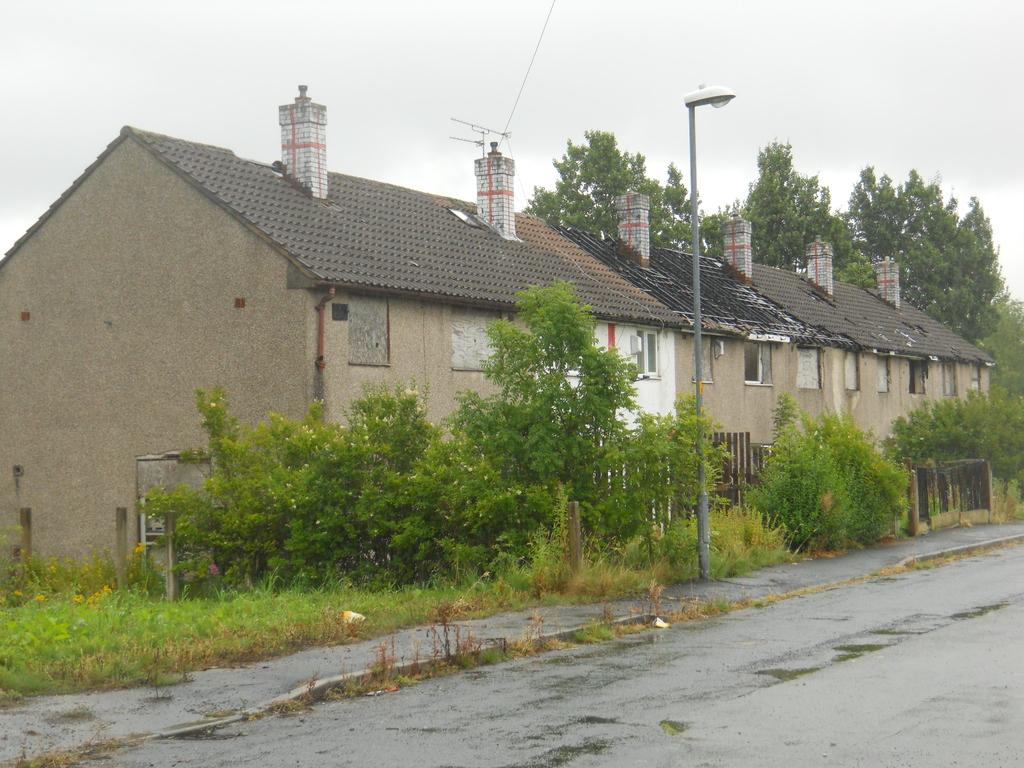What is in the foreground of the image? There is a road in the foreground of the image. What can be seen in the middle of the image? There are trees, poles, and a building in the middle of the image. What is visible at the top of the image? The sky is visible at the top of the image. How many bears are running on the roof in the image? There are no bears or roof present in the image. What type of roof is visible on the building in the image? There is no roof visible on the building in the image; only the building's facade is shown. 